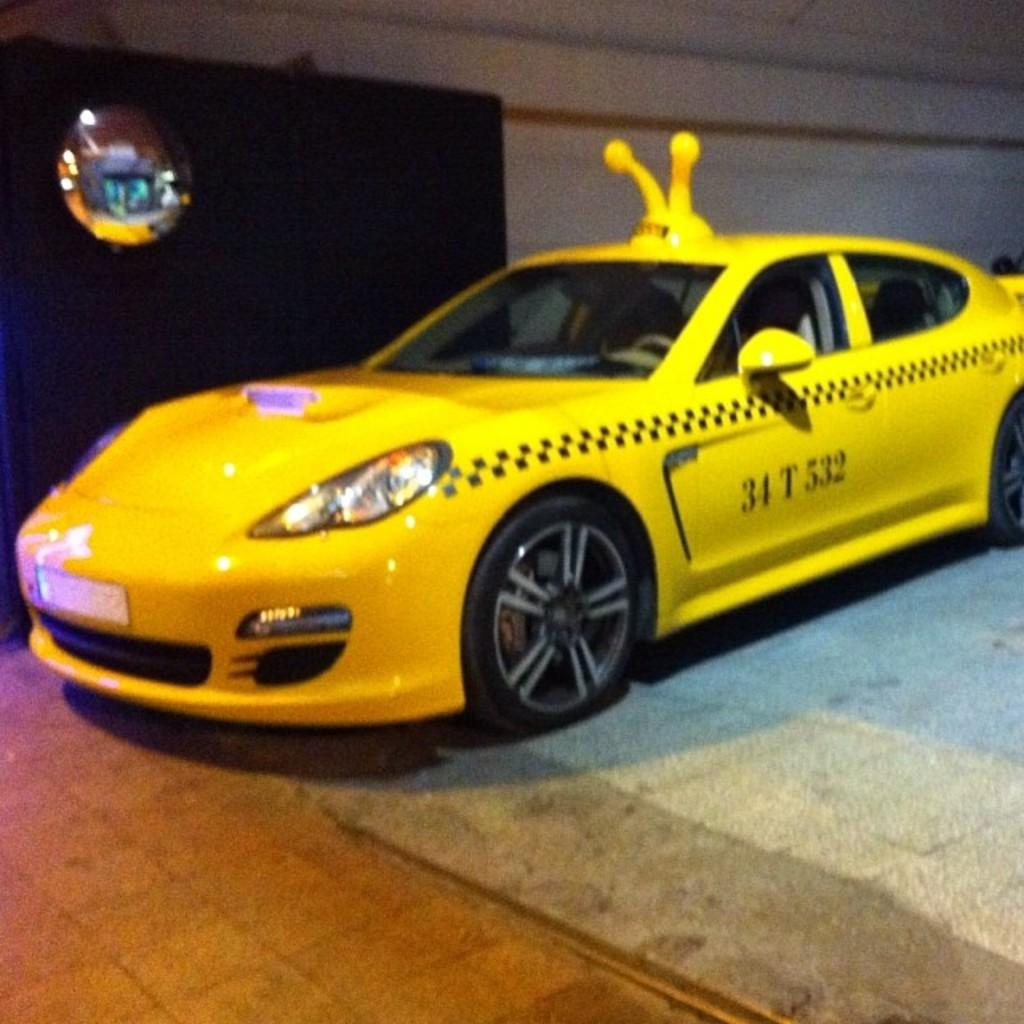Provide a one-sentence caption for the provided image. a car with the number 34 on the side of it. 